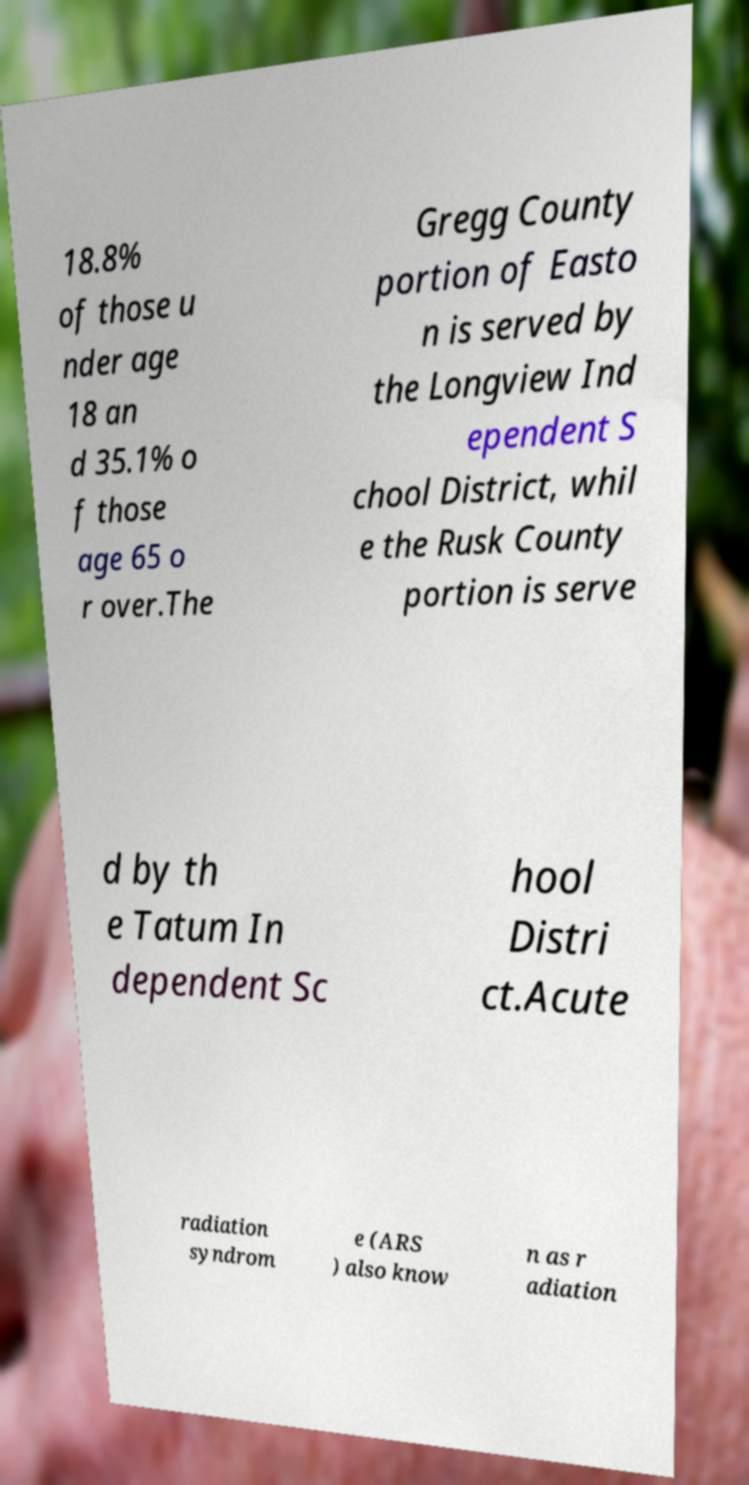I need the written content from this picture converted into text. Can you do that? 18.8% of those u nder age 18 an d 35.1% o f those age 65 o r over.The Gregg County portion of Easto n is served by the Longview Ind ependent S chool District, whil e the Rusk County portion is serve d by th e Tatum In dependent Sc hool Distri ct.Acute radiation syndrom e (ARS ) also know n as r adiation 